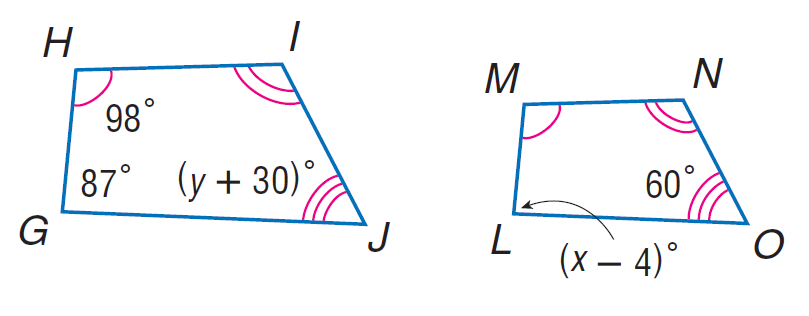Question: Each pair of polygons is similar. Find y.
Choices:
A. 30
B. 60
C. 87
D. 98
Answer with the letter. Answer: A Question: Each pair of polygons is similar. Find x.
Choices:
A. 60
B. 87
C. 91
D. 98
Answer with the letter. Answer: C 